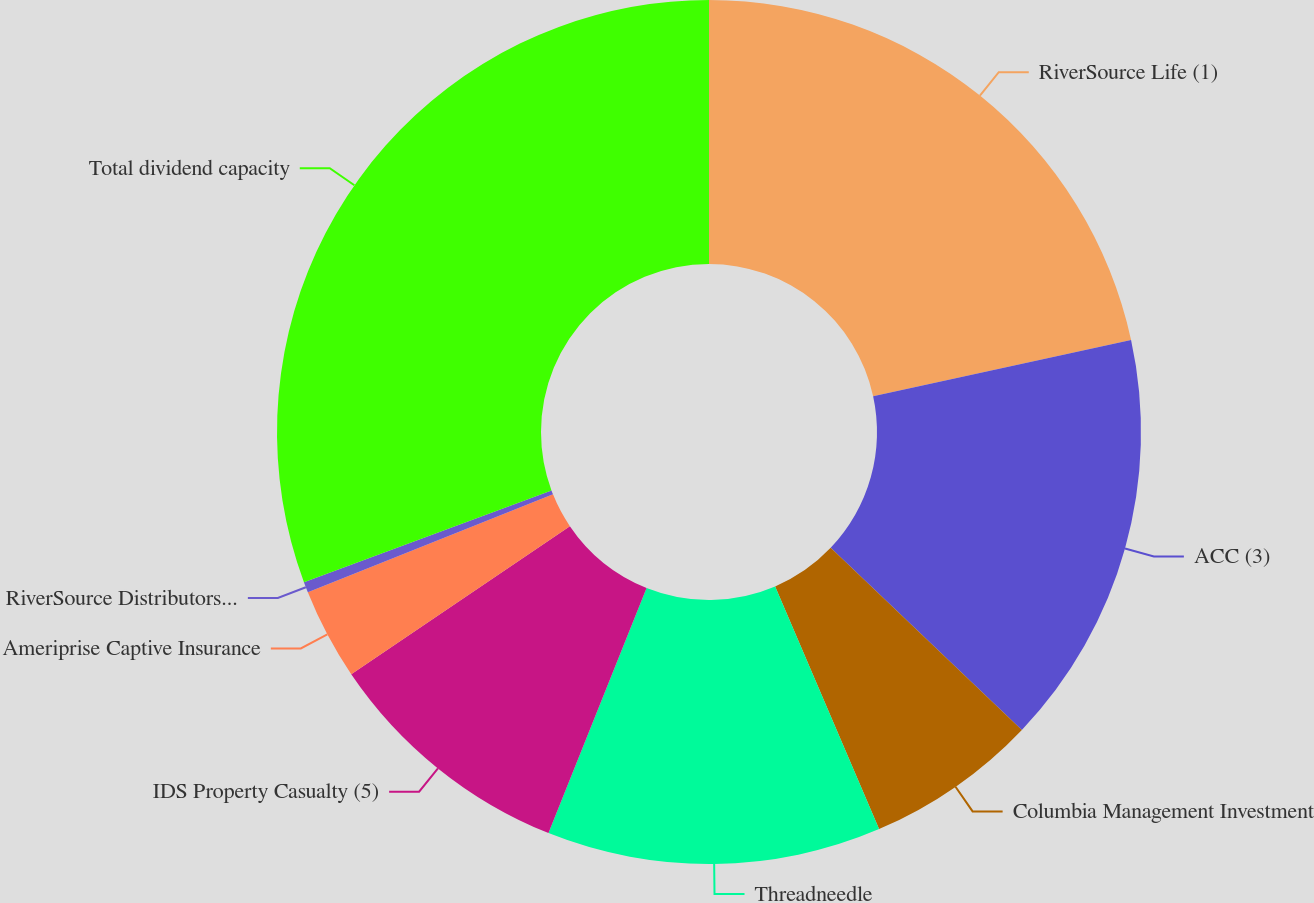<chart> <loc_0><loc_0><loc_500><loc_500><pie_chart><fcel>RiverSource Life (1)<fcel>ACC (3)<fcel>Columbia Management Investment<fcel>Threadneedle<fcel>IDS Property Casualty (5)<fcel>Ameriprise Captive Insurance<fcel>RiverSource Distributors Inc<fcel>Total dividend capacity<nl><fcel>21.58%<fcel>15.53%<fcel>6.45%<fcel>12.5%<fcel>9.47%<fcel>3.42%<fcel>0.4%<fcel>30.65%<nl></chart> 